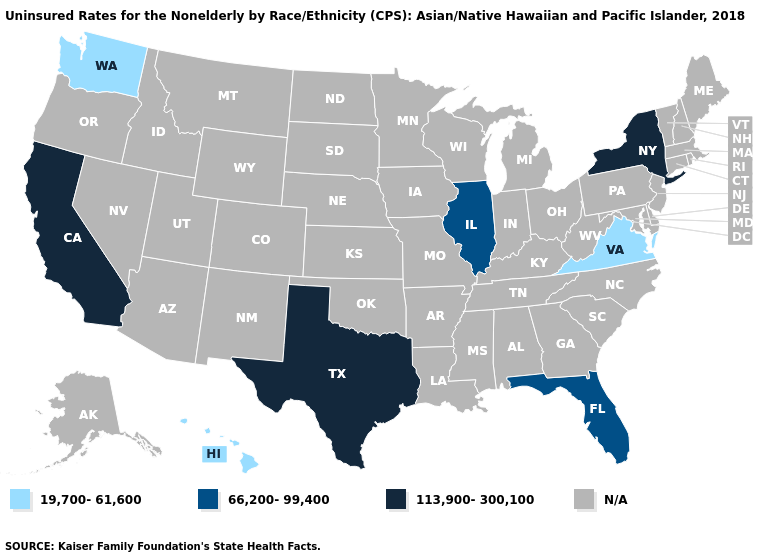What is the value of California?
Be succinct. 113,900-300,100. Name the states that have a value in the range 19,700-61,600?
Answer briefly. Hawaii, Virginia, Washington. Does the first symbol in the legend represent the smallest category?
Keep it brief. Yes. Name the states that have a value in the range 66,200-99,400?
Keep it brief. Florida, Illinois. Which states have the lowest value in the USA?
Quick response, please. Hawaii, Virginia, Washington. What is the highest value in states that border West Virginia?
Give a very brief answer. 19,700-61,600. Among the states that border Kentucky , which have the lowest value?
Write a very short answer. Virginia. Among the states that border Arizona , which have the lowest value?
Quick response, please. California. Name the states that have a value in the range 113,900-300,100?
Give a very brief answer. California, New York, Texas. What is the value of North Dakota?
Give a very brief answer. N/A. 